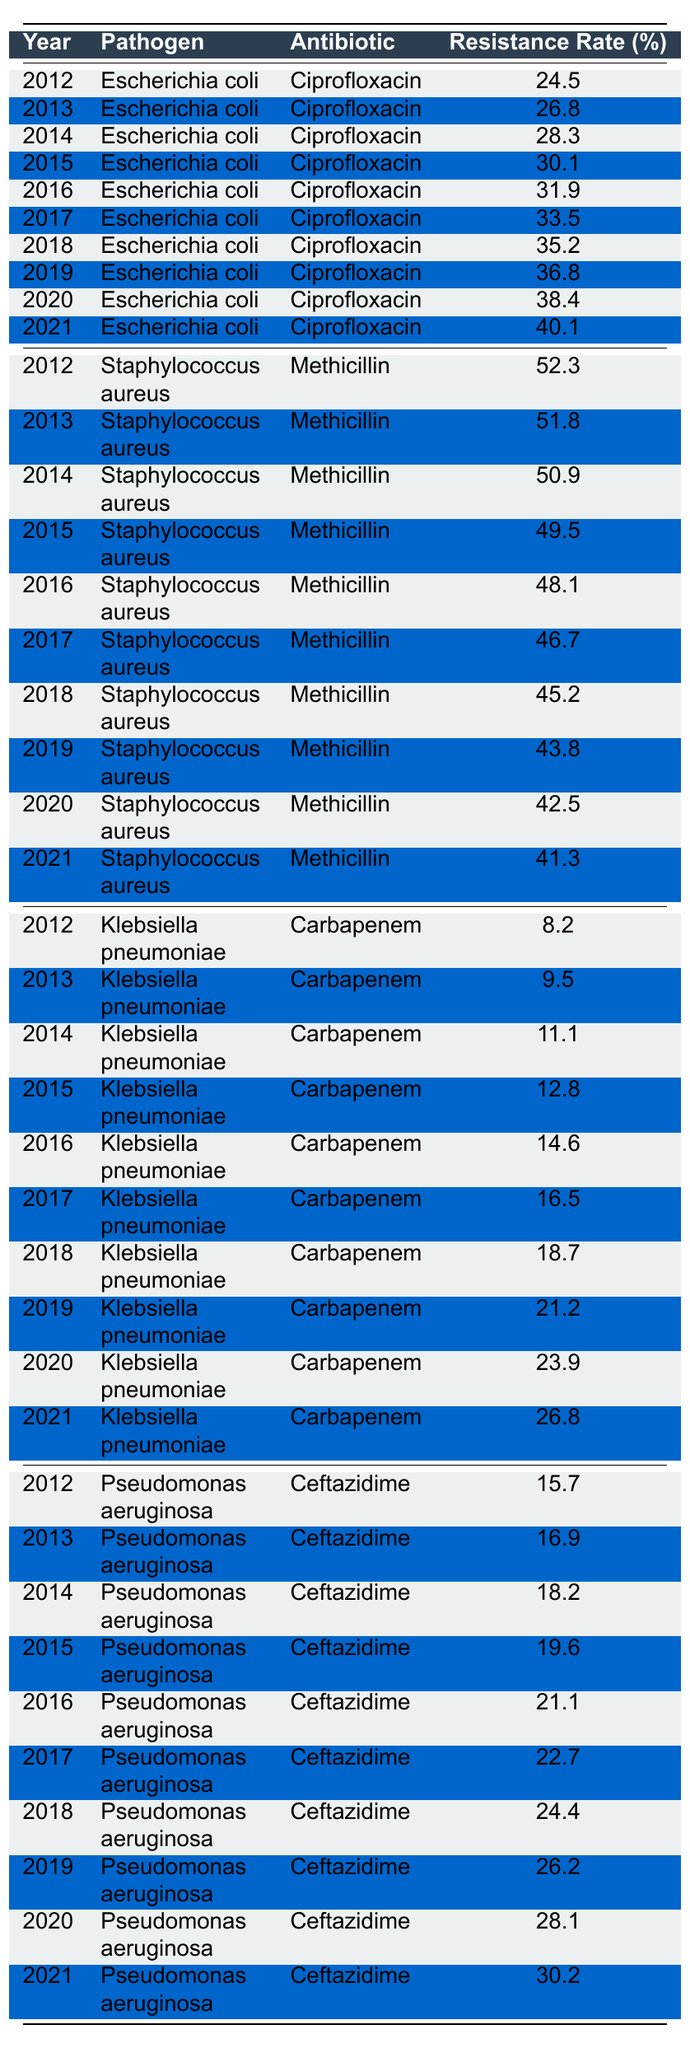What was the highest resistance rate for Escherichia coli in the given years? Looking at the table, the resistance rate for Escherichia coli with Ciprofloxacin increased every year from 2012 to 2021, reaching a peak of 40.1% in 2021.
Answer: 40.1% In which year did Klebsiella pneumoniae first exceed a resistance rate of 20% for Carbapenem? Referring to the data, Klebsiella pneumoniae's resistance rate for Carbapenem reached 21.2% in 2019, which is the first year it exceeds 20%.
Answer: 2019 What is the average resistance rate for Staphylococcus aureus to Methicillin over the years 2012 to 2021? The resistance rates summed across the years are 52.3, 51.8, 50.9, 49.5, 48.1, 46.7, 45.2, 43.8, 42.5, and 41.3, totaling 469.3. Dividing by the 10 years gives an average of 46.93%.
Answer: 46.93% Did the resistance rate for Pseudomonas aeruginosa to Ceftazidime increase each year? Analyzing the table, each subsequent year from 2012 to 2021 shows an increase in resistance rates for Pseudomonas aeruginosa to Ceftazidime, confirming it did increase every year.
Answer: Yes What was the difference in the resistance rate of Klebsiella pneumoniae to Carbapenem between 2012 and 2021? The rate in 2012 was 8.2%, and in 2021 it was 26.8%. The difference is calculated as 26.8% - 8.2% = 18.6%.
Answer: 18.6% Was there a year when the resistance rate for Staphylococcus aureus to Methicillin dropped below 45%? Checking the data, the lowest rate was 41.3% in 2021, which is below 45%, indicating that yes, there was a year where the rate dropped below this threshold.
Answer: Yes What is the trend of resistance rates for Escherichia coli to Ciprofloxacin over the years? The resistance rates for Escherichia coli to Ciprofloxacin show a consistent upward trend from 24.5% in 2012 to 40.1% in 2021, indicating increasing resistance over the years.
Answer: Increasing In which year did the resistance rate for Pseudomonas aeruginosa reach 28.1% for Ceftazidime? By checking the table, the resistance rate reached 28.1% in the year 2020.
Answer: 2020 What are the maximum and minimum resistance rates for Klebsiella pneumoniae to Carbapenem in the provided years? The maximum resistance rate is 26.8% in 2021, and the minimum is 8.2% in 2012, giving a range from 8.2% to 26.8%.
Answer: Max: 26.8%, Min: 8.2% What was the trend in resistance rates of Staphylococcus aureus to Methicillin from 2012 to 2021? An examination of the values shows a downward trend from 52.3% in 2012 to 41.3% in 2021, indicating a decrease in resistance rates for Staphylococcus aureus to Methicillin over these years.
Answer: Decreasing 